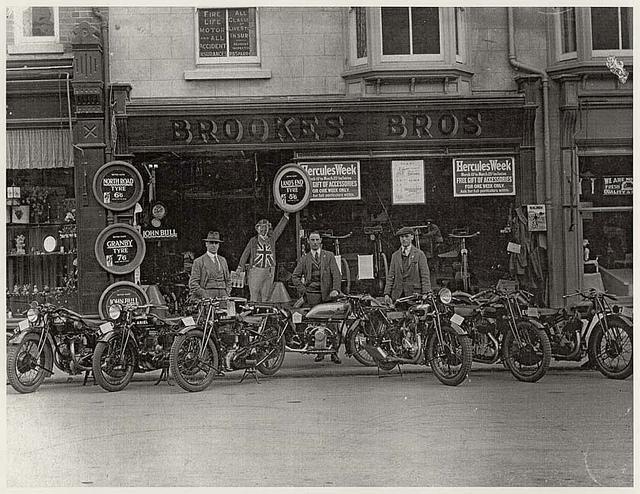What countries flag can be seen on the man's shirt?
Make your selection from the four choices given to correctly answer the question.
Options: Australia, united kingdom, china, africa. United kingdom. 